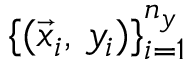Convert formula to latex. <formula><loc_0><loc_0><loc_500><loc_500>\{ ( \vec { x } _ { i } , \, y _ { i } ) \} _ { i = 1 } ^ { n _ { y } }</formula> 